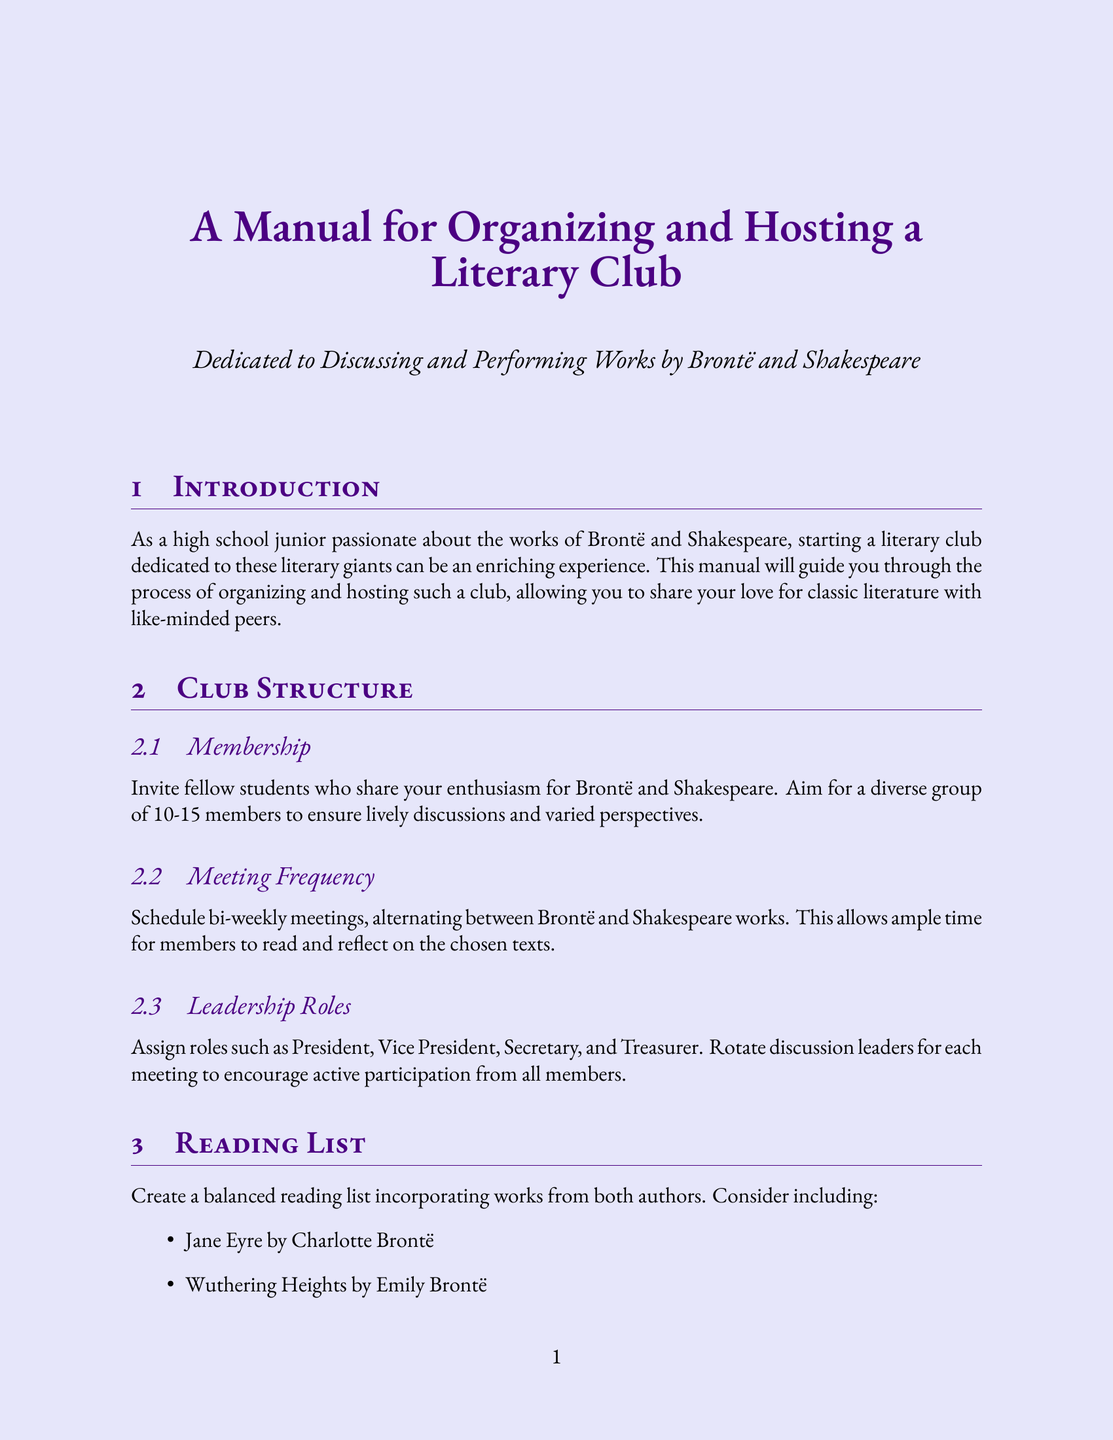What is the recommended membership size for the club? The manual suggests a diverse group of 10-15 members for lively discussions and varied perspectives.
Answer: 10-15 members How often should the club meet? The document states that bi-weekly meetings should be scheduled, alternating between Brontë and Shakespeare works.
Answer: Bi-weekly Which play is suggested for scene readings? Key scenes from Shakespeare's plays such as the balcony scene from Romeo and Juliet are mentioned.
Answer: Romeo and Juliet What theme is proposed for comparison in discussions? The manual suggests comparing the treatment of love in Wuthering Heights and Romeo and Juliet as a thematic comparison.
Answer: Treatment of love What type of activities are suggested for author birthdays? The manual mentions celebrating with themed parties and activities, specifically for author birthdays.
Answer: Themed parties Who were the authors celebrated for their birthdays? The document lists Charlotte Brontë, Emily Brontë, and William Shakespeare as authors to celebrate.
Answer: Charlotte Brontë, Emily Brontë, William Shakespeare What is one suggested performance activity? The document recommends modernized adaptations where members write and perform contemporary settings of literary works.
Answer: Modernized adaptations 